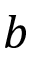<formula> <loc_0><loc_0><loc_500><loc_500>b</formula> 